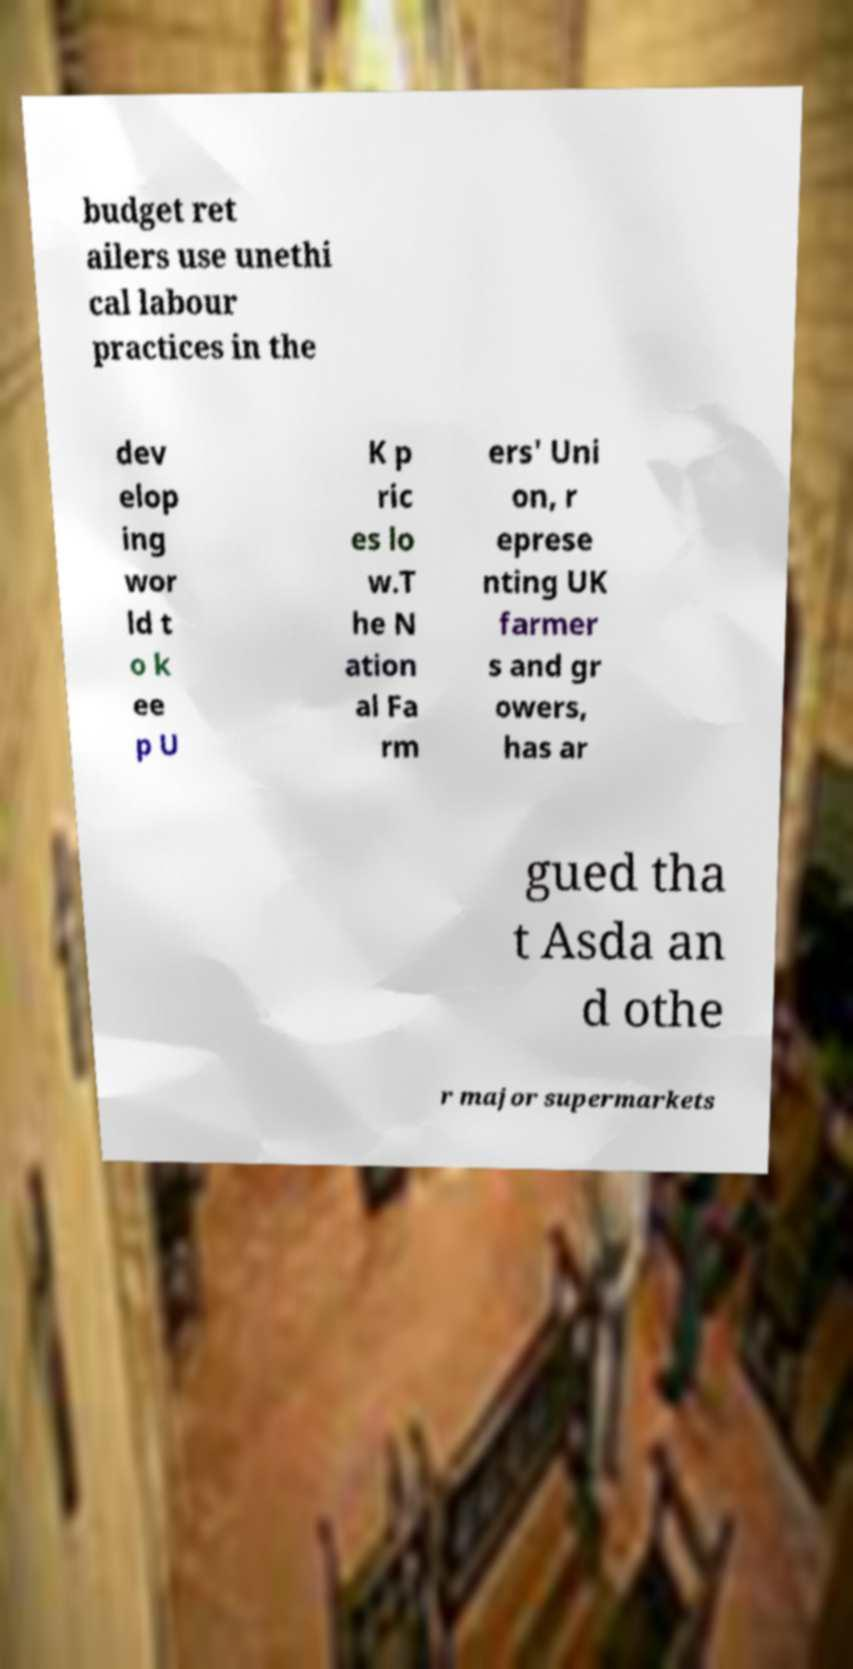Could you assist in decoding the text presented in this image and type it out clearly? budget ret ailers use unethi cal labour practices in the dev elop ing wor ld t o k ee p U K p ric es lo w.T he N ation al Fa rm ers' Uni on, r eprese nting UK farmer s and gr owers, has ar gued tha t Asda an d othe r major supermarkets 